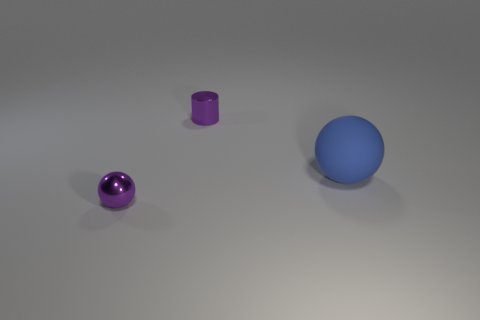What number of other objects are there of the same size as the metallic cylinder? There is one object that appears to be of the same size as the metallic cylinder, which is the blue sphere. 